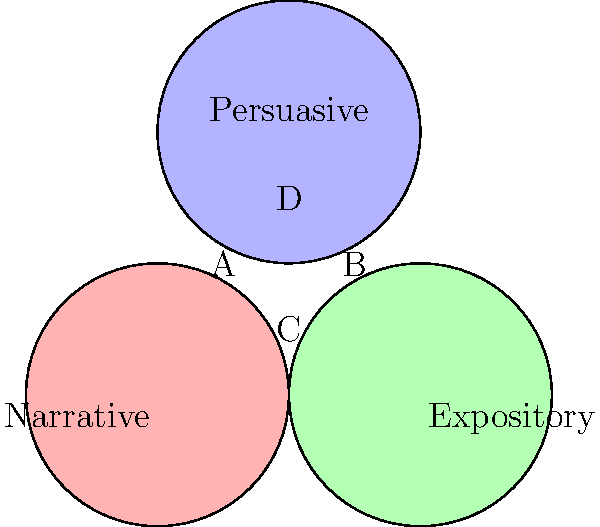In the Venn diagram above, three main writing styles are represented: Narrative, Expository, and Persuasive. Which area (labeled A, B, C, or D) represents writing that incorporates elements of all three styles? To answer this question, we need to analyze the Venn diagram and understand what each area represents:

1. The circle on the left represents Narrative writing.
2. The circle on the right represents Expository writing.
3. The circle at the top represents Persuasive writing.
4. Area A is the overlap between Narrative and Persuasive, but not Expository.
5. Area B is the overlap between Expository and Persuasive, but not Narrative.
6. Area C is the overlap between Narrative and Expository, but not Persuasive.
7. Area D is the central region where all three circles overlap.

The question asks for the area that incorporates elements of all three styles. This would be the region where all three circles intersect, which is area D.

As a versatile writer experienced in various industries, understanding how different writing styles can overlap and complement each other is crucial. This knowledge allows you to adapt your writing to different client needs and create more engaging content by combining elements from multiple styles.
Answer: D 